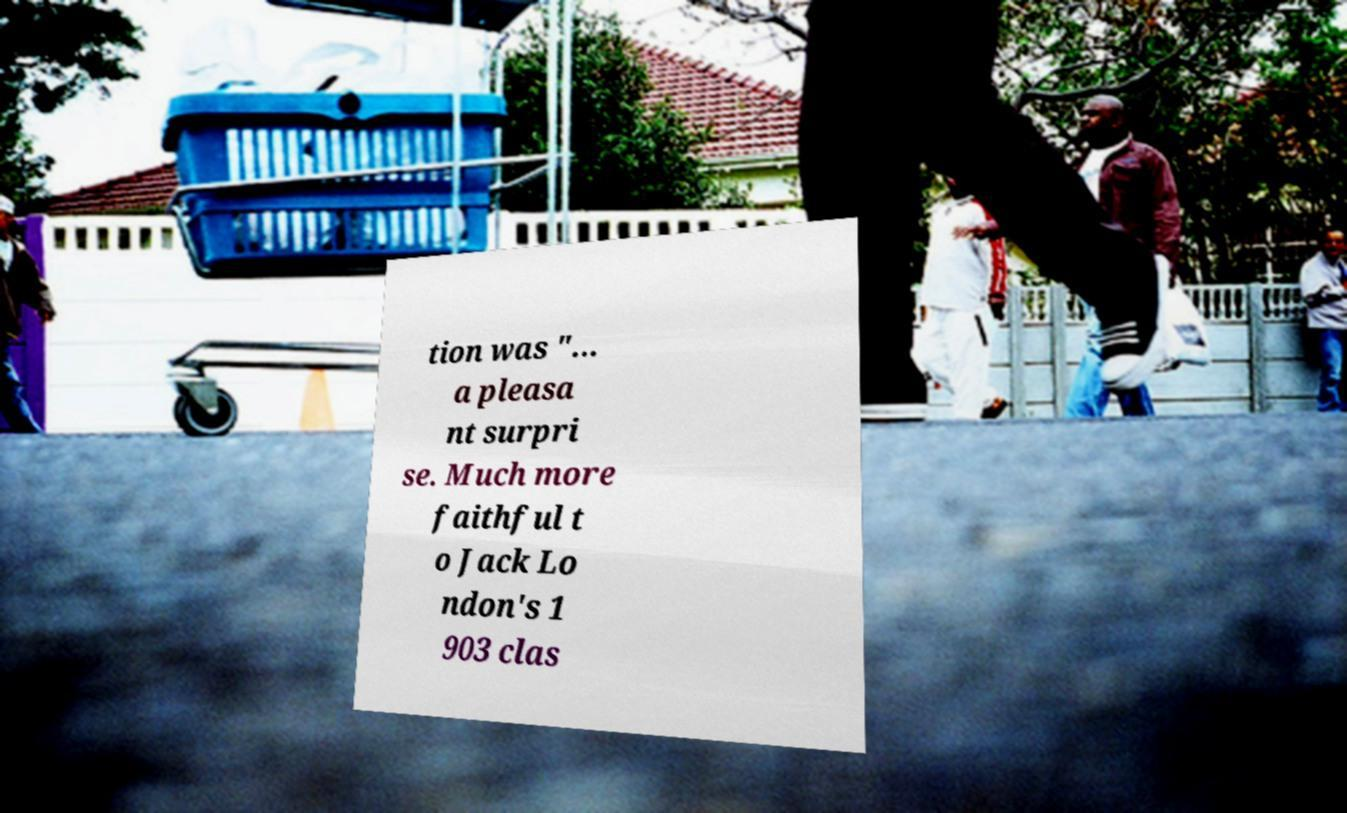Could you assist in decoding the text presented in this image and type it out clearly? tion was "... a pleasa nt surpri se. Much more faithful t o Jack Lo ndon's 1 903 clas 